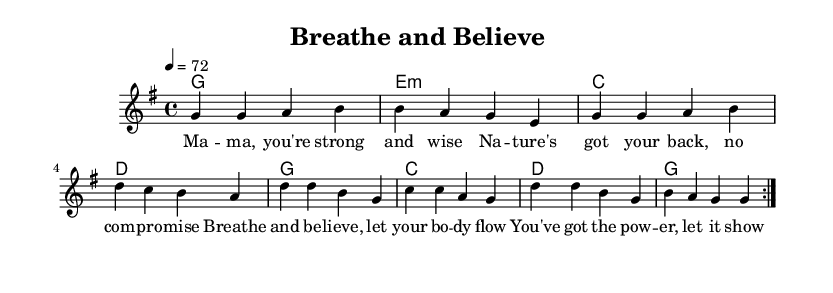What is the key signature of this music? The key signature is G major, which includes one sharp (F#). This can be identified by looking at the key signature displayed at the beginning of the staff.
Answer: G major What is the time signature of this piece? The time signature is 4/4, which means there are four beats in each measure and the quarter note gets one beat. This is indicated at the beginning of the score.
Answer: 4/4 What is the tempo marking of the piece? The tempo marking is indicated as 4 = 72, meaning there are 72 quarter-note beats per minute. This provides guidance on the speed at which the piece should be played.
Answer: 72 How many measures are in the repeated section? The repeated section contains eight measures in total. This can be counted from the repeats shown in both the melody and chord sections.
Answer: 8 What is the first lyric line of the verse? The first lyric line states "Ma -- ma, you're strong and wise". This can be seen by examining the lyrics written under the melody in the score.
Answer: Ma -- ma, you're strong and wise What chords are used in the chorus section? The chords used in the repeated section are G, E minor, C, and D. These can be identified by looking at the chord names written above the measures in the score.
Answer: G, E minor, C, D What type of music does this piece represent? This piece represents reggae music, characterized by its rhythmic style and themes of empowerment and nature. It fits into the reggae genre due to its upbeat and positive lyrical content.
Answer: Reggae 